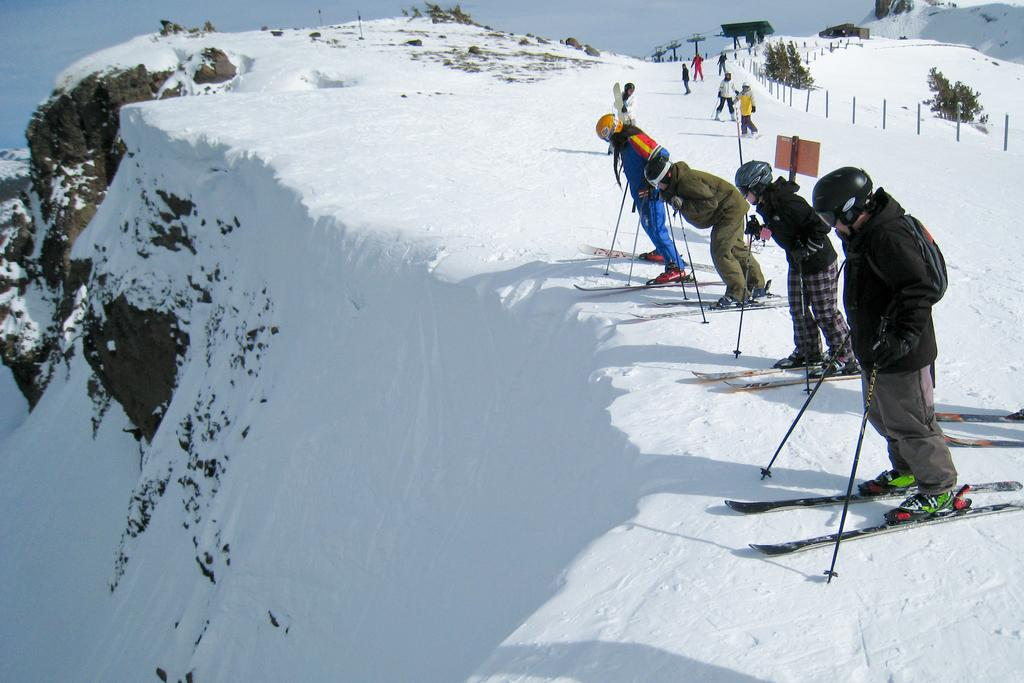Who or what is present in the image? There are people in the image. What activity are the people engaged in? The people are riding ski in the image. What is the color of the snow in the image? The snow in the image is white. What type of noise can be heard coming from the clouds in the image? There are no clouds present in the image, and therefore no noise can be heard coming from them. 